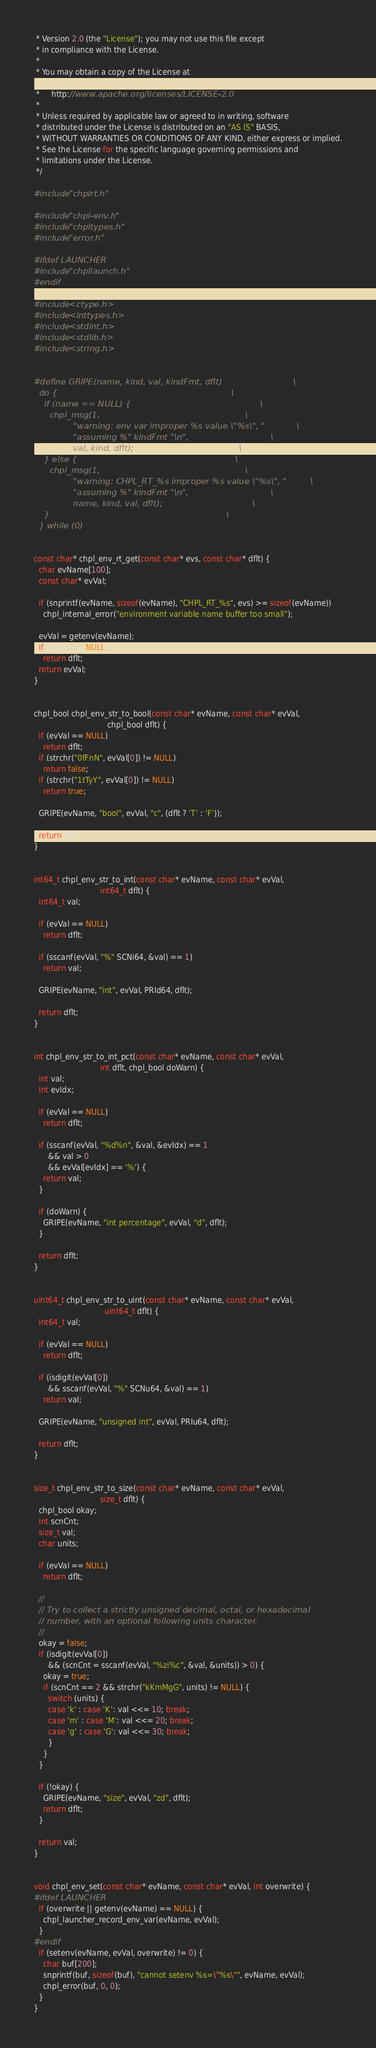Convert code to text. <code><loc_0><loc_0><loc_500><loc_500><_C_> * Version 2.0 (the "License"); you may not use this file except
 * in compliance with the License.
 * 
 * You may obtain a copy of the License at
 * 
 *     http://www.apache.org/licenses/LICENSE-2.0
 * 
 * Unless required by applicable law or agreed to in writing, software
 * distributed under the License is distributed on an "AS IS" BASIS,
 * WITHOUT WARRANTIES OR CONDITIONS OF ANY KIND, either express or implied.
 * See the License for the specific language governing permissions and
 * limitations under the License.
 */

#include "chplrt.h"

#include "chpl-env.h"
#include "chpltypes.h"
#include "error.h"

#ifdef LAUNCHER
#include "chpllaunch.h"
#endif

#include <ctype.h>
#include <inttypes.h>
#include <stdint.h>
#include <stdlib.h>
#include <string.h>


#define GRIPE(name, kind, val, kindFmt, dflt)                           \
  do {                                                                  \
    if (name == NULL) {                                                 \
      chpl_msg(1,                                                       \
               "warning: env var improper %s value \"%s\", "            \
               "assuming %" kindFmt "\n",                               \
               val, kind, dflt);                                        \
    } else {                                                            \
      chpl_msg(1,                                                       \
               "warning: CHPL_RT_%s improper %s value \"%s\", "         \
               "assuming %" kindFmt "\n",                               \
               name, kind, val, dflt);                                  \
    }                                                                   \
  } while (0)


const char* chpl_env_rt_get(const char* evs, const char* dflt) {
  char evName[100];
  const char* evVal;

  if (snprintf(evName, sizeof(evName), "CHPL_RT_%s", evs) >= sizeof(evName))
    chpl_internal_error("environment variable name buffer too small");

  evVal = getenv(evName);
  if (evVal == NULL)
    return dflt;
  return evVal;
}


chpl_bool chpl_env_str_to_bool(const char* evName, const char* evVal,
                               chpl_bool dflt) {
  if (evVal == NULL)
    return dflt;
  if (strchr("0fFnN", evVal[0]) != NULL)
    return false;
  if (strchr("1tTyY", evVal[0]) != NULL)
    return true;

  GRIPE(evName, "bool", evVal, "c", (dflt ? 'T' : 'F'));

  return dflt;
}


int64_t chpl_env_str_to_int(const char* evName, const char* evVal,
                            int64_t dflt) {
  int64_t val;

  if (evVal == NULL)
    return dflt;

  if (sscanf(evVal, "%" SCNi64, &val) == 1)
    return val;

  GRIPE(evName, "int", evVal, PRId64, dflt);

  return dflt;
}


int chpl_env_str_to_int_pct(const char* evName, const char* evVal,
                            int dflt, chpl_bool doWarn) {
  int val;
  int evIdx;

  if (evVal == NULL)
    return dflt;

  if (sscanf(evVal, "%d%n", &val, &evIdx) == 1
      && val > 0
      && evVal[evIdx] == '%') {
    return val;
  }

  if (doWarn) {
    GRIPE(evName, "int percentage", evVal, "d", dflt);
  }

  return dflt;
}


uint64_t chpl_env_str_to_uint(const char* evName, const char* evVal,
                              uint64_t dflt) {
  int64_t val;

  if (evVal == NULL)
    return dflt;

  if (isdigit(evVal[0])
      && sscanf(evVal, "%" SCNu64, &val) == 1)
    return val;

  GRIPE(evName, "unsigned int", evVal, PRIu64, dflt);

  return dflt;
}


size_t chpl_env_str_to_size(const char* evName, const char* evVal,
                            size_t dflt) {
  chpl_bool okay;
  int scnCnt;
  size_t val;
  char units;

  if (evVal == NULL)
    return dflt;

  //
  // Try to collect a strictly unsigned decimal, octal, or hexadecimal
  // number, with an optional following units character.
  //
  okay = false;
  if (isdigit(evVal[0])
      && (scnCnt = sscanf(evVal, "%zi%c", &val, &units)) > 0) {
    okay = true;
    if (scnCnt == 2 && strchr("kKmMgG", units) != NULL) {
      switch (units) {
      case 'k' : case 'K': val <<= 10; break;
      case 'm' : case 'M': val <<= 20; break;
      case 'g' : case 'G': val <<= 30; break;
      }
    }
  }

  if (!okay) {
    GRIPE(evName, "size", evVal, "zd", dflt);
    return dflt;
  }

  return val;
}


void chpl_env_set(const char* evName, const char* evVal, int overwrite) {
#ifdef LAUNCHER
  if (overwrite || getenv(evName) == NULL) {
    chpl_launcher_record_env_var(evName, evVal);
  }
#endif
  if (setenv(evName, evVal, overwrite) != 0) {
    char buf[200];
    snprintf(buf, sizeof(buf), "cannot setenv %s=\"%s\"", evName, evVal);
    chpl_error(buf, 0, 0);
  }
}

</code> 